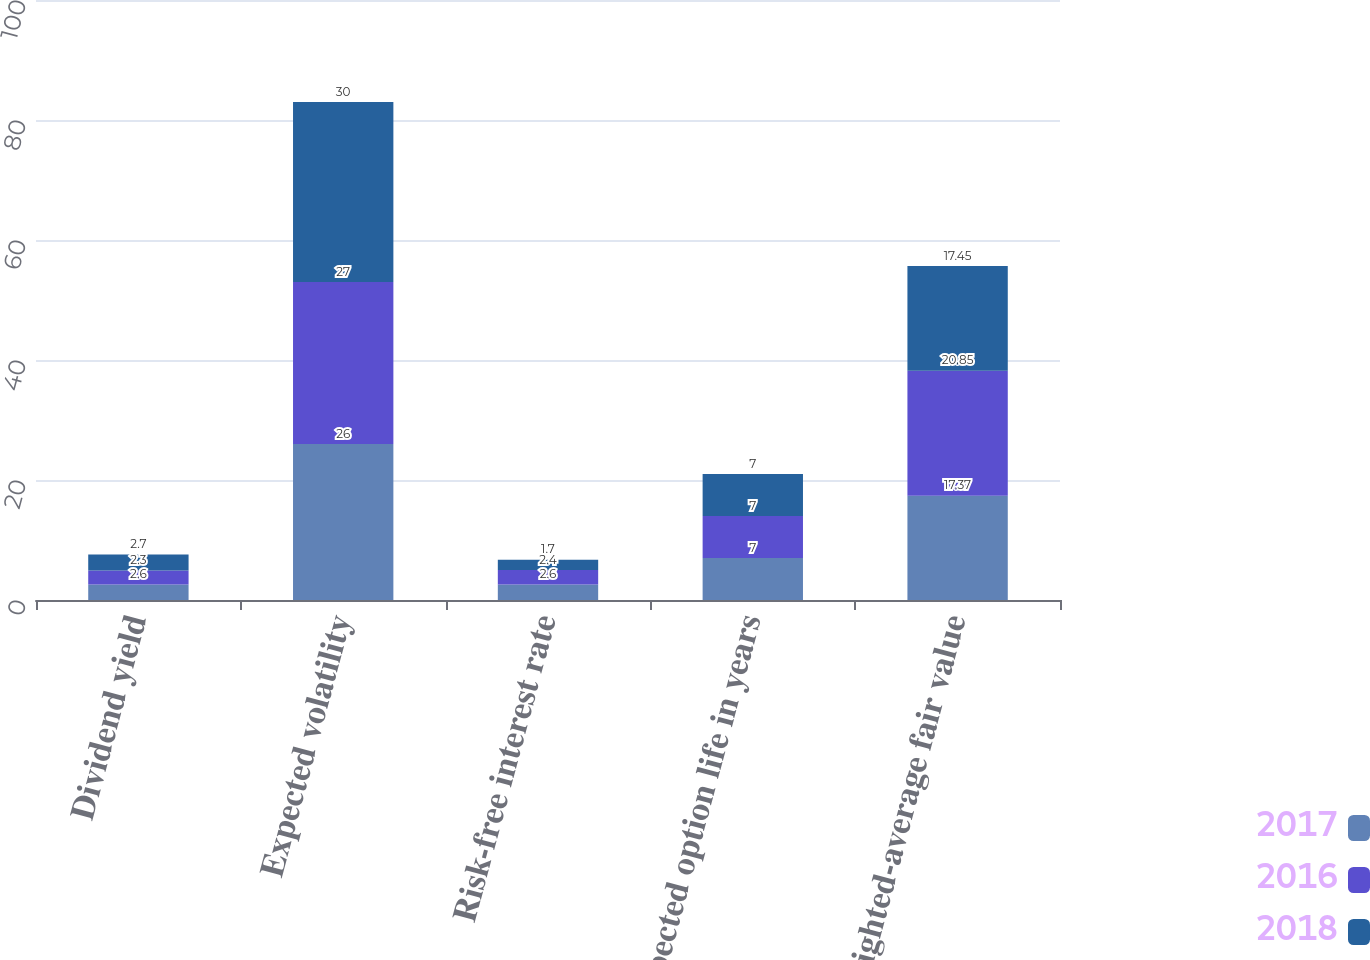Convert chart. <chart><loc_0><loc_0><loc_500><loc_500><stacked_bar_chart><ecel><fcel>Dividend yield<fcel>Expected volatility<fcel>Risk-free interest rate<fcel>Expected option life in years<fcel>Weighted-average fair value<nl><fcel>2017<fcel>2.6<fcel>26<fcel>2.6<fcel>7<fcel>17.37<nl><fcel>2016<fcel>2.3<fcel>27<fcel>2.4<fcel>7<fcel>20.85<nl><fcel>2018<fcel>2.7<fcel>30<fcel>1.7<fcel>7<fcel>17.45<nl></chart> 